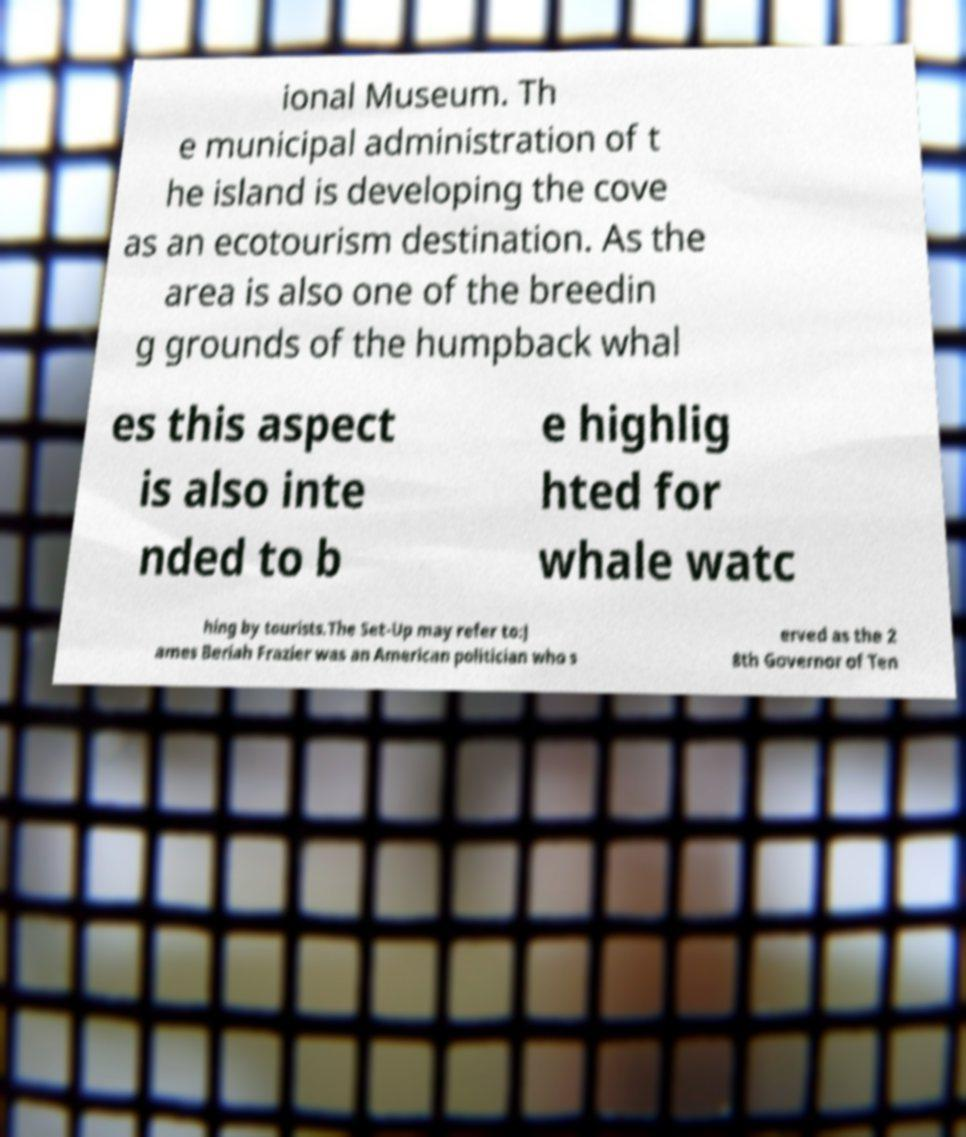Please read and relay the text visible in this image. What does it say? ional Museum. Th e municipal administration of t he island is developing the cove as an ecotourism destination. As the area is also one of the breedin g grounds of the humpback whal es this aspect is also inte nded to b e highlig hted for whale watc hing by tourists.The Set-Up may refer to:J ames Beriah Frazier was an American politician who s erved as the 2 8th Governor of Ten 